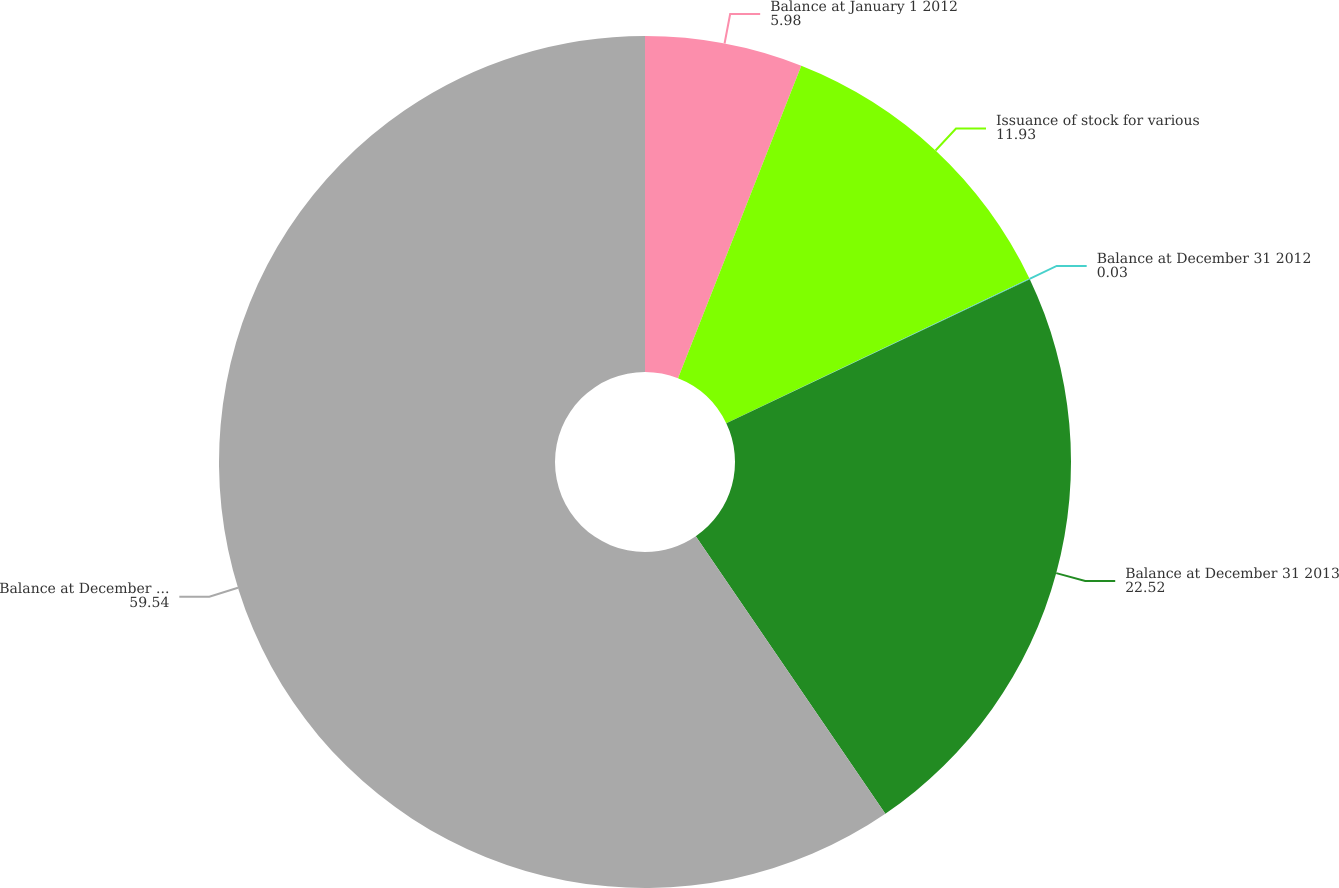<chart> <loc_0><loc_0><loc_500><loc_500><pie_chart><fcel>Balance at January 1 2012<fcel>Issuance of stock for various<fcel>Balance at December 31 2012<fcel>Balance at December 31 2013<fcel>Balance at December 31 2014<nl><fcel>5.98%<fcel>11.93%<fcel>0.03%<fcel>22.52%<fcel>59.54%<nl></chart> 